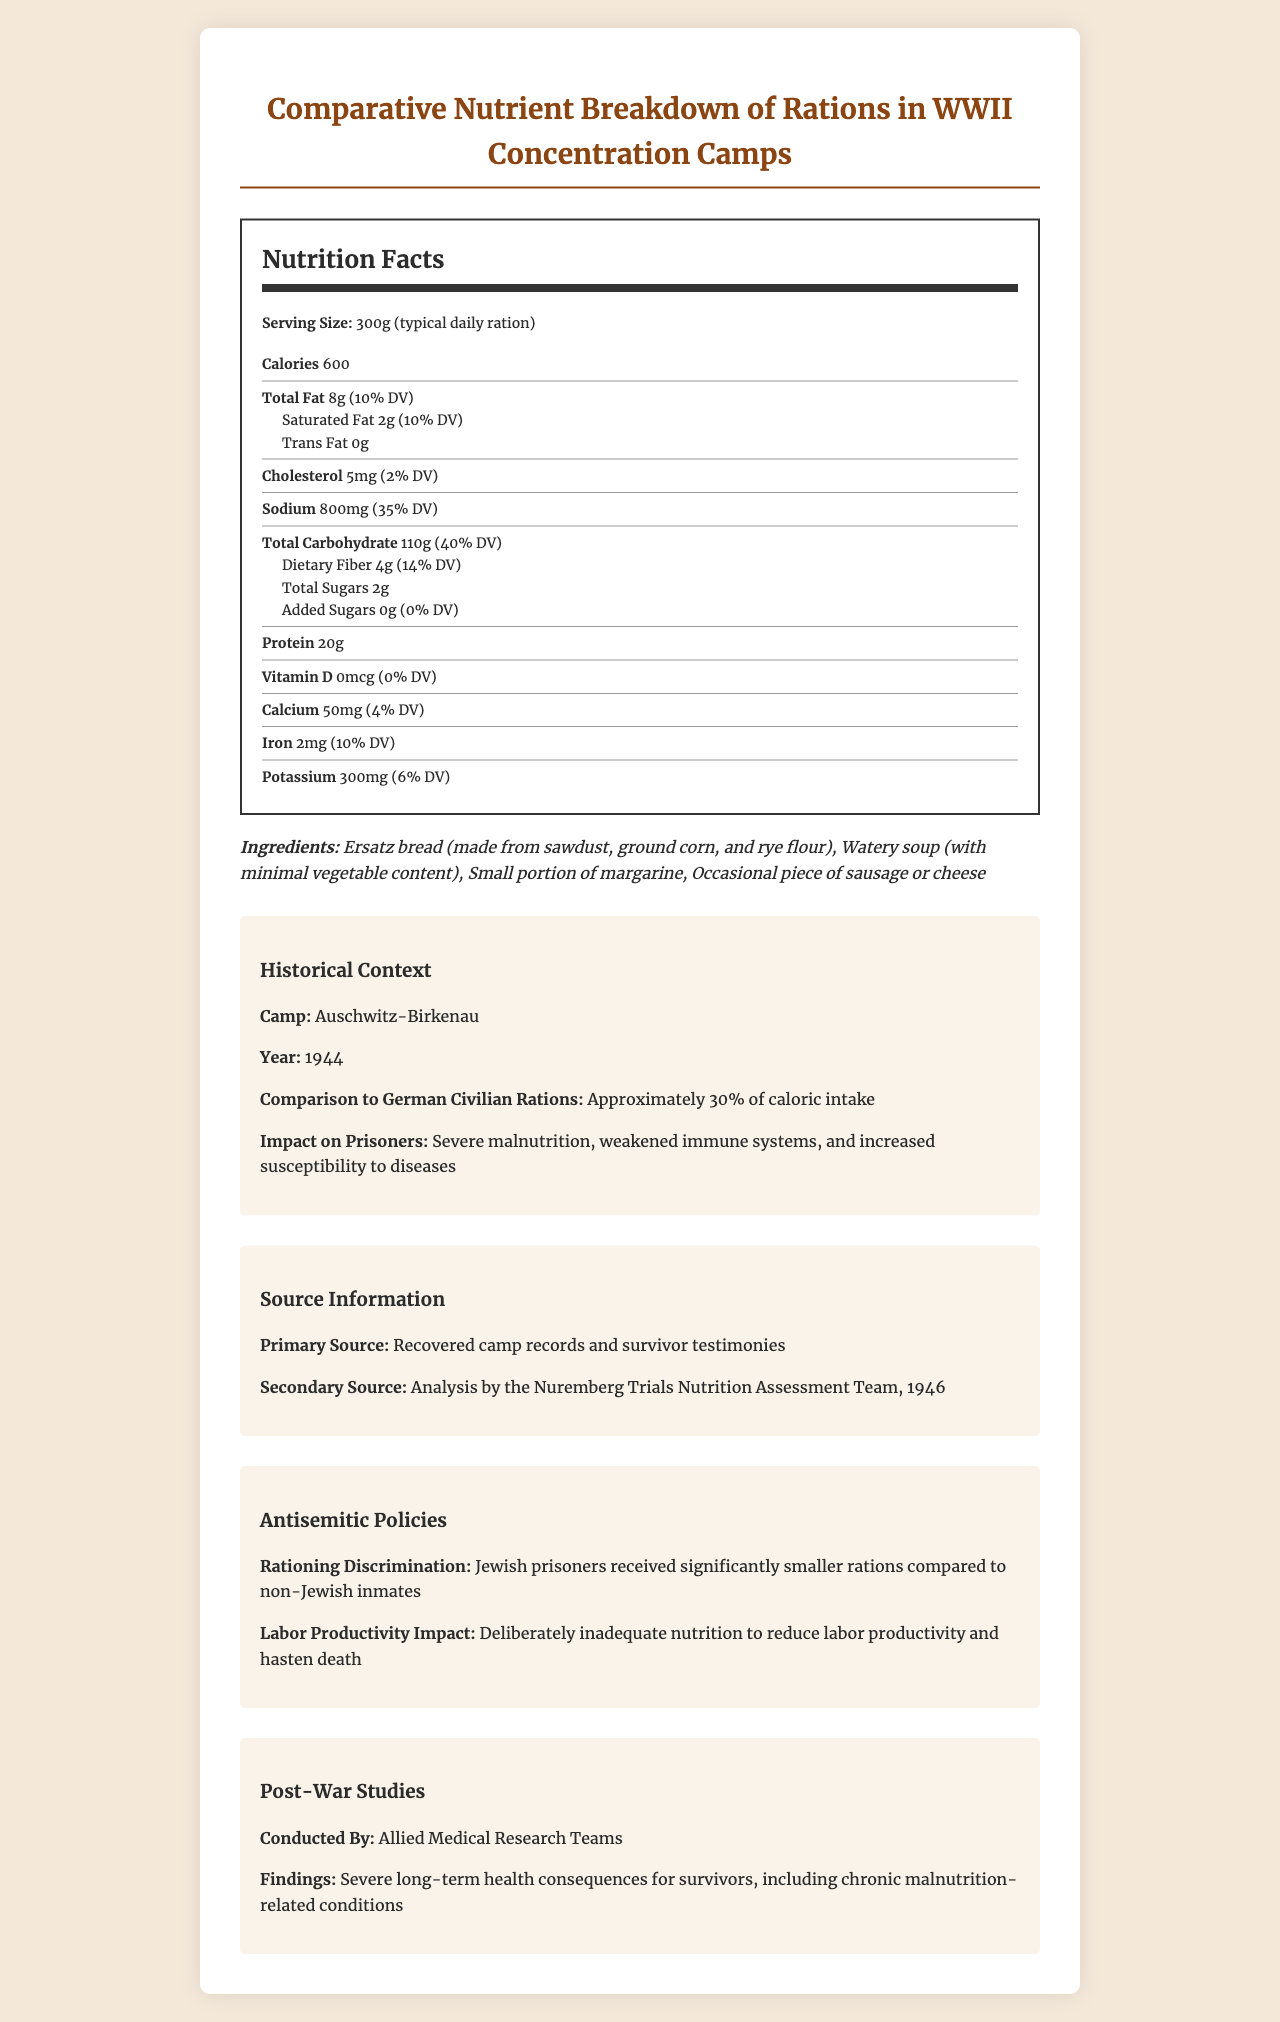what is the serving size? The document states the serving size as 300g, which is considered a typical daily ration.
Answer: 300g How many calories are in the daily ration? The document lists the calorie content of the daily ration as 600 calories.
Answer: 600 What are the main ingredients in the concentration camp ration? The document specifies the ingredients as Ersatz bread, watery soup, a small portion of margarine, and occasional pieces of sausage or cheese.
Answer: Ersatz bread, watery soup, small portion of margarine, occasional piece of sausage or cheese How much protein does the ration provide? The document indicates that the daily ration provides 20g of protein.
Answer: 20g What was the approximate percentage of caloric intake compared to German civilian rations? The document notes that the rations were approximately 30% of the caloric intake compared to German civilian rations.
Answer: 30% Which nutrient has the highest percentage of the daily value? A. Sodium B. Total Carbohydrate C. Protein Total Carbohydrate at 40% DV is the highest percentage compared to sodium (35% DV) and protein (40% DV).
Answer: B What was the impact of the rations on the prisoners' health? A. Improved immune systems B. Severe malnutrition C. Enhanced labor productivity D. Increased caloric intake The document mentions that the impact on prisoners was "Severe malnutrition, weakened immune systems, and increased susceptibility to diseases".
Answer: B Did Jewish prisoners receive the same amount of rations as non-Jewish inmates? The document states that Jewish prisoners received significantly smaller rations compared to non-Jewish inmates.
Answer: No Which micronutrient has a daily value percentage of 0% in the ration? According to the document, Vitamin D has a 0% daily value in the ration.
Answer: Vitamin D What is the main idea of the document? The document provides a detailed breakdown of the nutrient content of rations in WWII concentration camps, their severe impact on prisoners' health, and the antisemitic policies related to rationing.
Answer: Comparative analysis of rations in WWII concentration camps, highlighting nutritional deficiencies and impact on prisoners. Who conducted the post-war studies on the health consequences for survivors? The document notes that post-war studies were conducted by Allied Medical Research Teams.
Answer: Allied Medical Research Teams What is the amount of sodium in the daily ration? The document lists the sodium content of the daily ration as 800mg.
Answer: 800mg Which organization assessed the nutrition based on the secondary source? The secondary source information in the document indicates the assessment was done by the Nuremberg Trials Nutrition Assessment Team, 1946.
Answer: Nuremberg Trials Nutrition Assessment Team, 1946 How many grams of dietary fiber are in the daily ration? The document specifies that there are 4 grams of dietary fiber in the daily ration.
Answer: 4g What was the impact of the inadequate nutrition on labor productivity in concentration camps? The document mentions that deliberately inadequate nutrition was aimed to reduce labor productivity and hasten death.
Answer: Reduced labor productivity and hastened death Do we know the exact percentage of Jewish prisoners compared to the total prisoner population from this document? The document does not provide any information on the percentage of Jewish prisoners compared to the total prisoner population.
Answer: Cannot be determined 